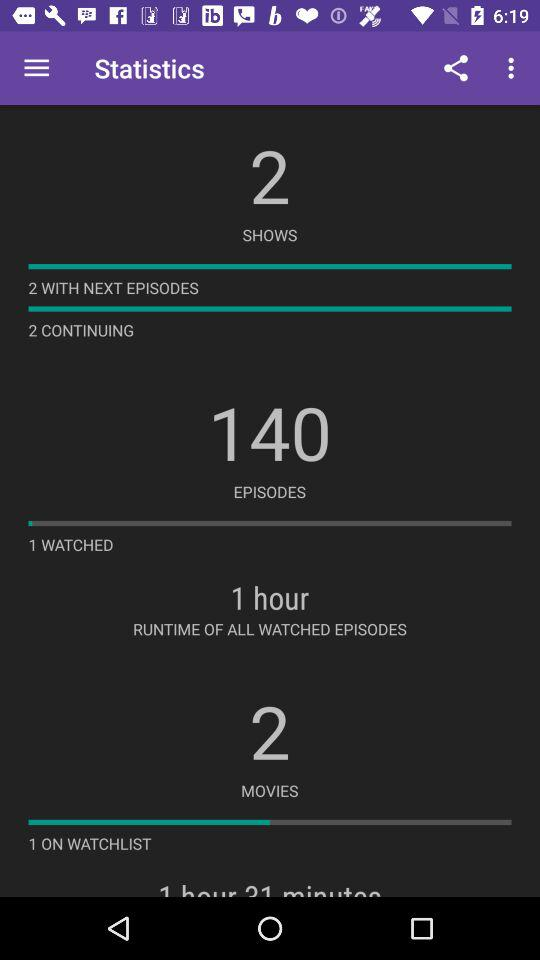What is the runtime of all watched episodes? The runtime of all watched episodes is 1 hour. 